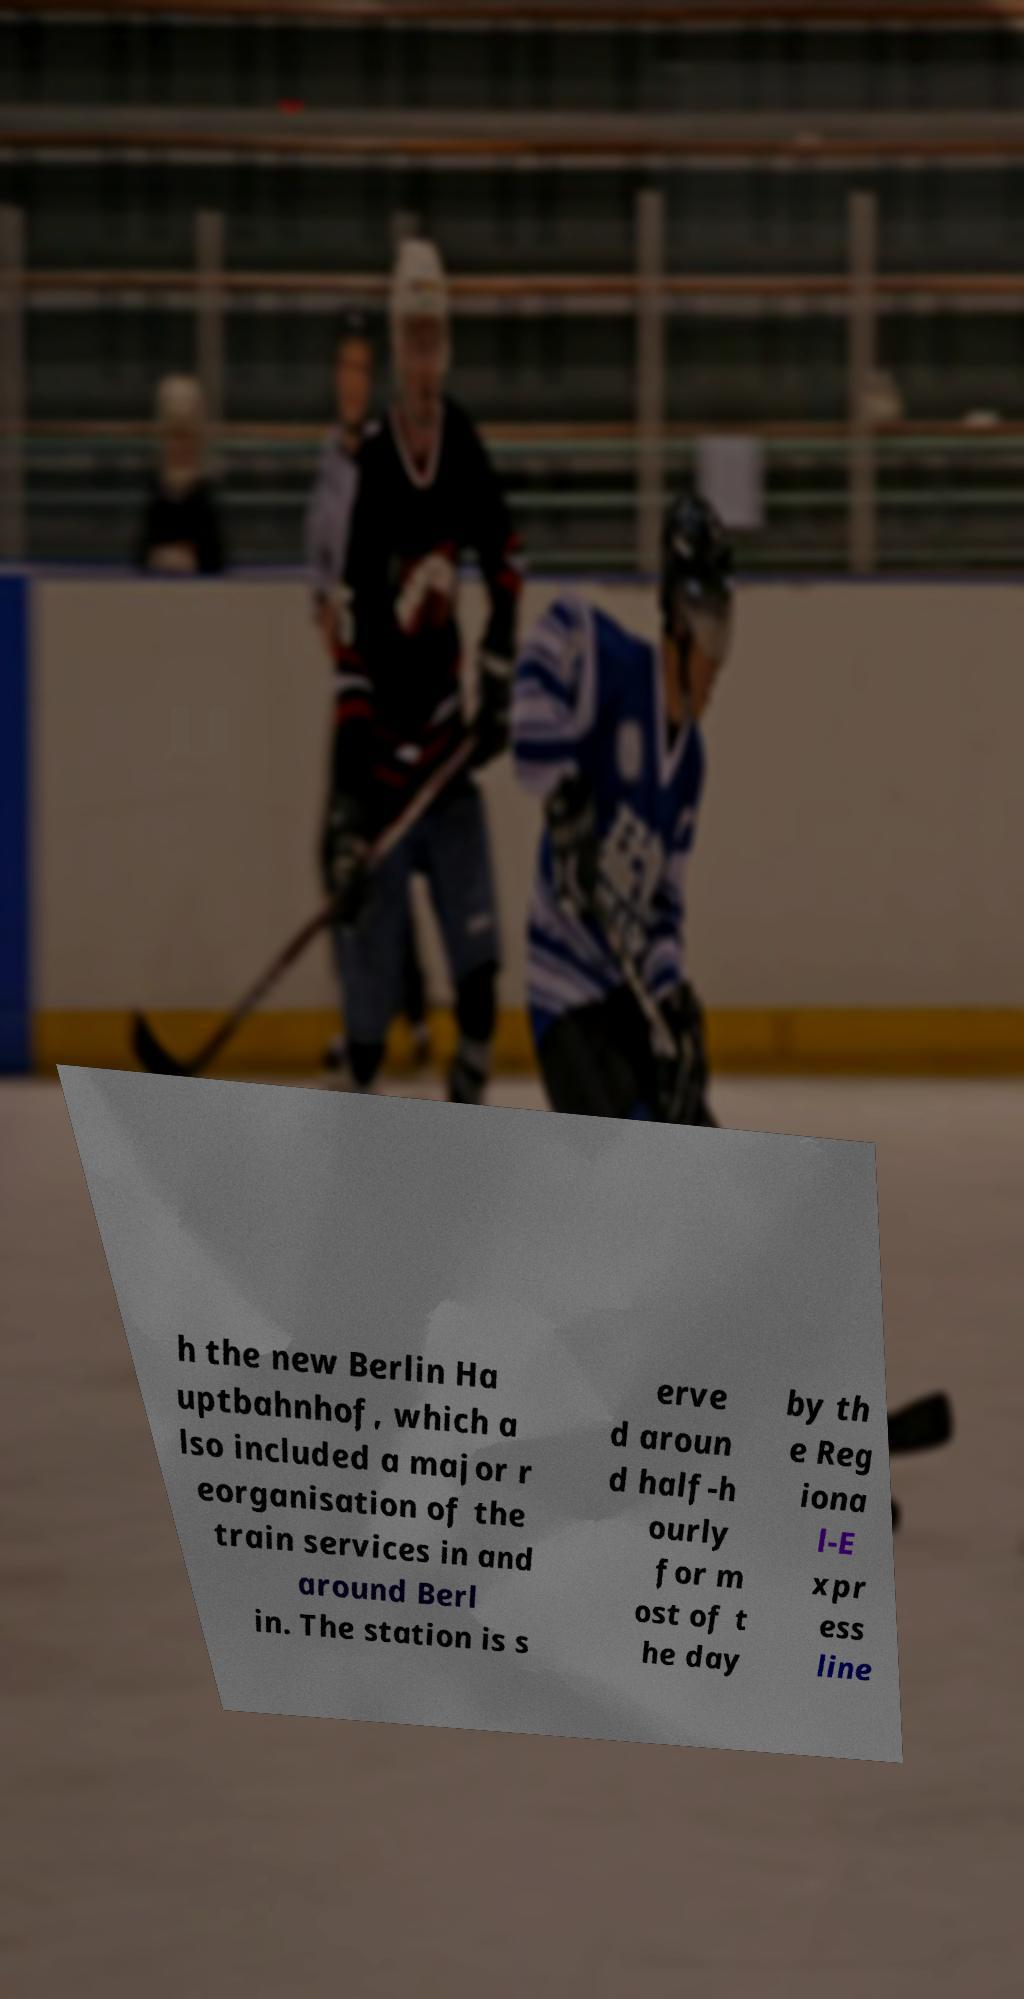Could you assist in decoding the text presented in this image and type it out clearly? h the new Berlin Ha uptbahnhof, which a lso included a major r eorganisation of the train services in and around Berl in. The station is s erve d aroun d half-h ourly for m ost of t he day by th e Reg iona l-E xpr ess line 